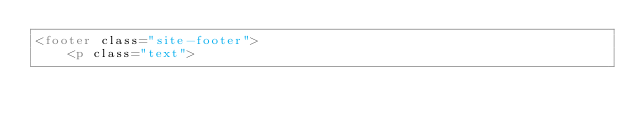Convert code to text. <code><loc_0><loc_0><loc_500><loc_500><_HTML_><footer class="site-footer">
    <p class="text"></code> 